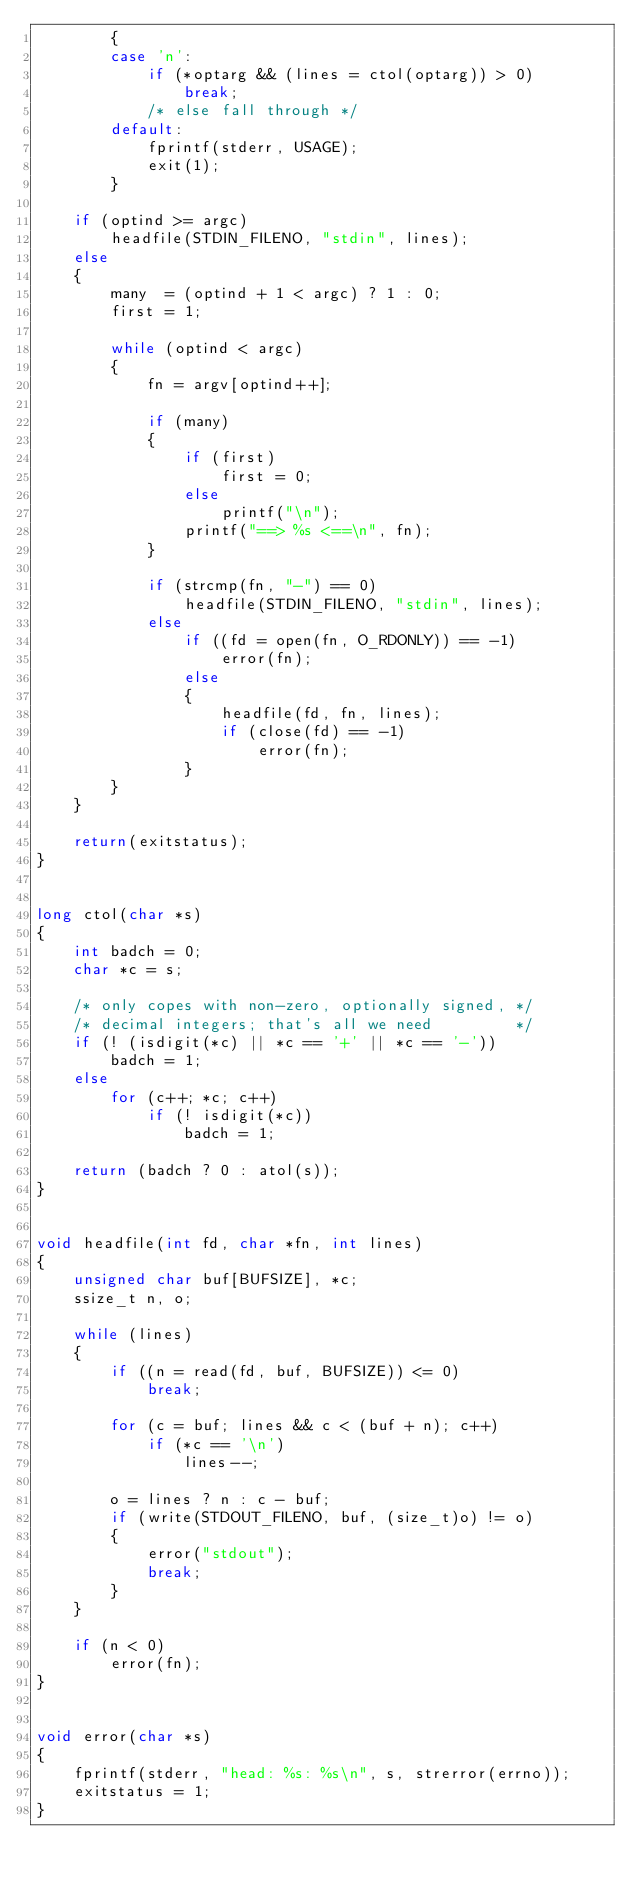<code> <loc_0><loc_0><loc_500><loc_500><_C_>        {
        case 'n':
            if (*optarg && (lines = ctol(optarg)) > 0)
                break;
            /* else fall through */
        default:
            fprintf(stderr, USAGE);
            exit(1);
        }

    if (optind >= argc)
        headfile(STDIN_FILENO, "stdin", lines);
    else
    {
        many  = (optind + 1 < argc) ? 1 : 0;
        first = 1;

        while (optind < argc)
        {
            fn = argv[optind++];

            if (many)
            {
                if (first)
                    first = 0;
                else
                    printf("\n");
                printf("==> %s <==\n", fn);
            }

            if (strcmp(fn, "-") == 0)
                headfile(STDIN_FILENO, "stdin", lines);
            else
                if ((fd = open(fn, O_RDONLY)) == -1)
                    error(fn);
                else
                {
                    headfile(fd, fn, lines);
                    if (close(fd) == -1)
                        error(fn);
                }
        }
    }

    return(exitstatus);
}


long ctol(char *s)
{
    int badch = 0;
    char *c = s;

    /* only copes with non-zero, optionally signed, */
    /* decimal integers; that's all we need         */
    if (! (isdigit(*c) || *c == '+' || *c == '-'))
        badch = 1;
    else
        for (c++; *c; c++)
            if (! isdigit(*c))
                badch = 1;

    return (badch ? 0 : atol(s));
}


void headfile(int fd, char *fn, int lines)
{
    unsigned char buf[BUFSIZE], *c;
    ssize_t n, o;

    while (lines)
    {
        if ((n = read(fd, buf, BUFSIZE)) <= 0)
            break;

        for (c = buf; lines && c < (buf + n); c++)
            if (*c == '\n')
                lines--;

        o = lines ? n : c - buf;
        if (write(STDOUT_FILENO, buf, (size_t)o) != o)
        {
            error("stdout");
            break;
        }
    }

    if (n < 0)
        error(fn);
}


void error(char *s)
{
    fprintf(stderr, "head: %s: %s\n", s, strerror(errno));
    exitstatus = 1;
}
</code> 